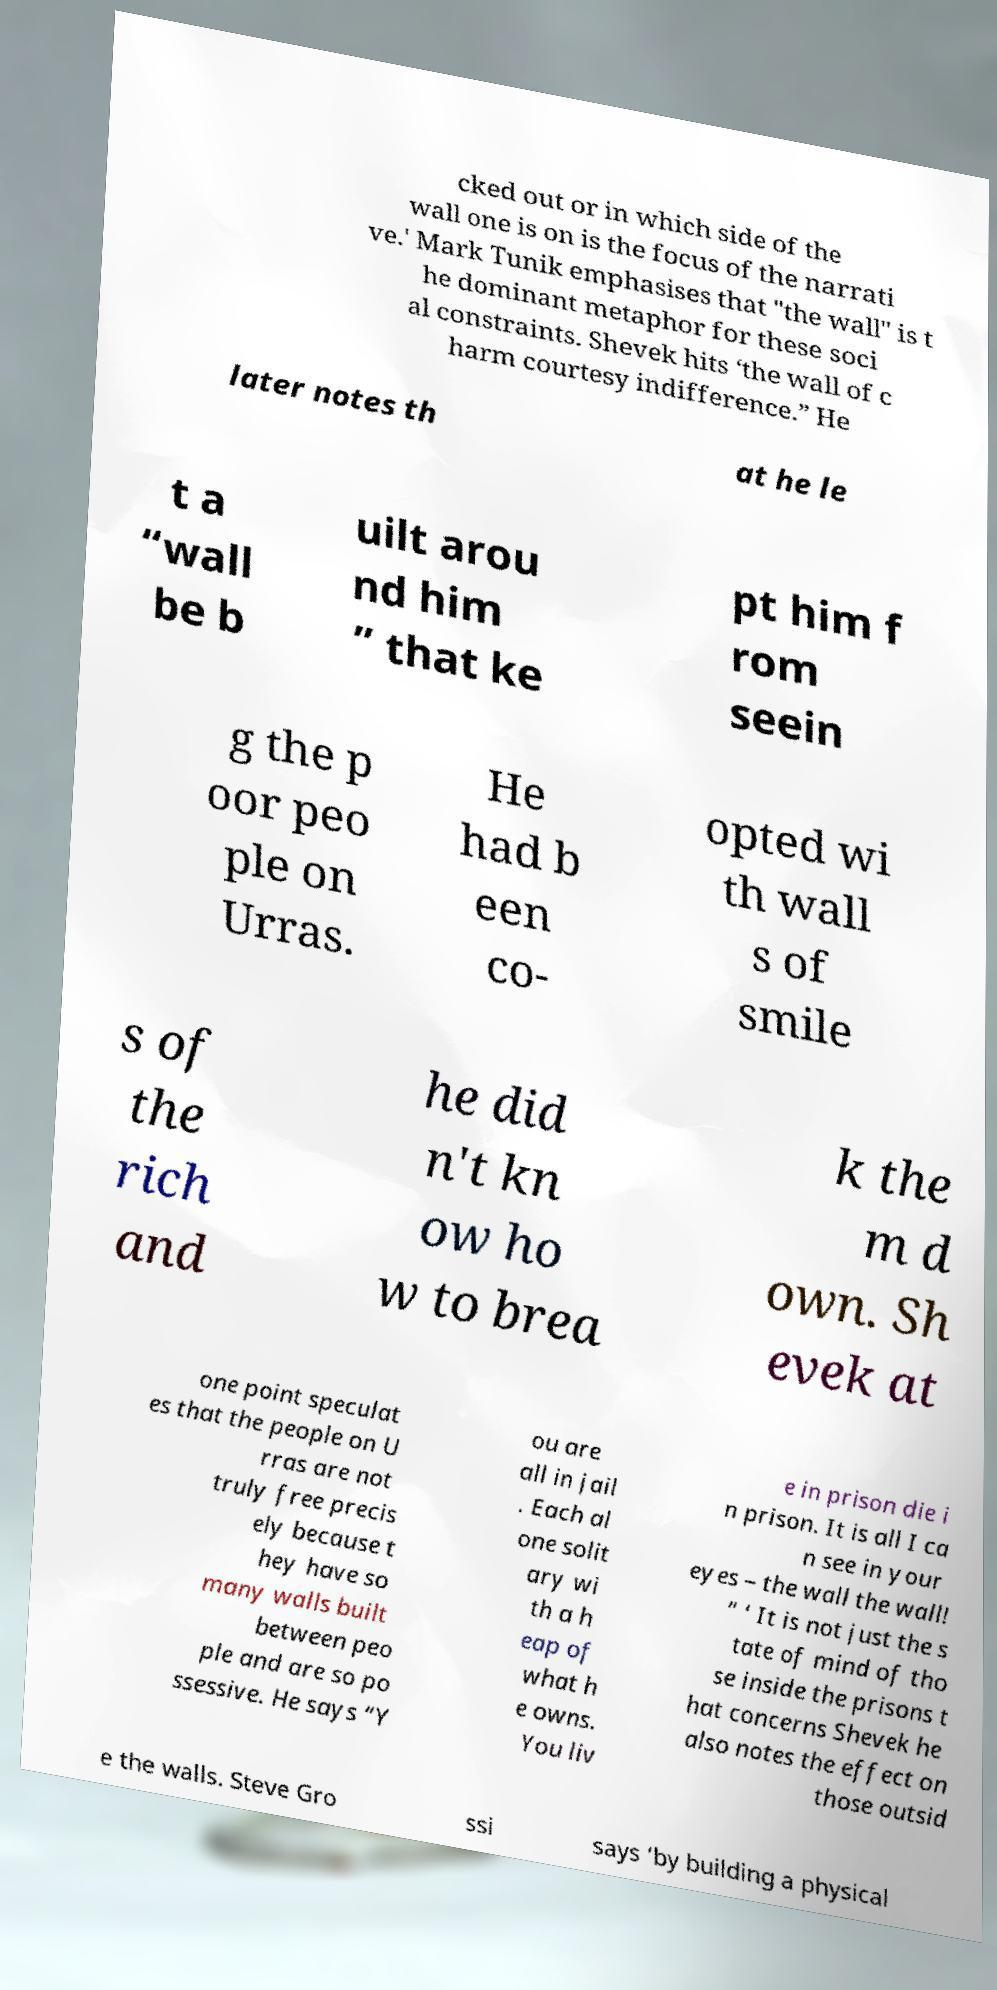I need the written content from this picture converted into text. Can you do that? cked out or in which side of the wall one is on is the focus of the narrati ve.' Mark Tunik emphasises that "the wall" is t he dominant metaphor for these soci al constraints. Shevek hits ‘the wall of c harm courtesy indifference.” He later notes th at he le t a “wall be b uilt arou nd him ” that ke pt him f rom seein g the p oor peo ple on Urras. He had b een co- opted wi th wall s of smile s of the rich and he did n't kn ow ho w to brea k the m d own. Sh evek at one point speculat es that the people on U rras are not truly free precis ely because t hey have so many walls built between peo ple and are so po ssessive. He says “Y ou are all in jail . Each al one solit ary wi th a h eap of what h e owns. You liv e in prison die i n prison. It is all I ca n see in your eyes – the wall the wall! ” ‘ It is not just the s tate of mind of tho se inside the prisons t hat concerns Shevek he also notes the effect on those outsid e the walls. Steve Gro ssi says ‘by building a physical 